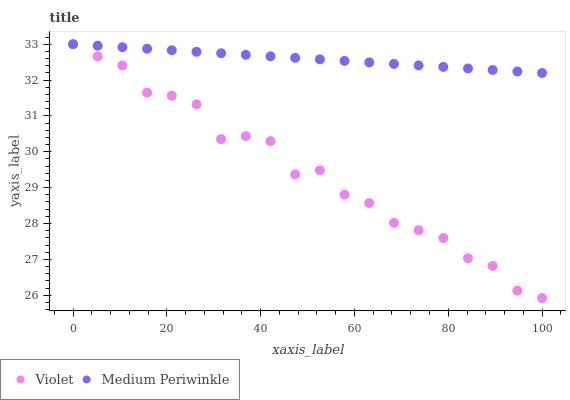Does Violet have the minimum area under the curve?
Answer yes or no. Yes. Does Medium Periwinkle have the maximum area under the curve?
Answer yes or no. Yes. Does Violet have the maximum area under the curve?
Answer yes or no. No. Is Medium Periwinkle the smoothest?
Answer yes or no. Yes. Is Violet the roughest?
Answer yes or no. Yes. Is Violet the smoothest?
Answer yes or no. No. Does Violet have the lowest value?
Answer yes or no. Yes. Does Violet have the highest value?
Answer yes or no. Yes. Does Medium Periwinkle intersect Violet?
Answer yes or no. Yes. Is Medium Periwinkle less than Violet?
Answer yes or no. No. Is Medium Periwinkle greater than Violet?
Answer yes or no. No. 